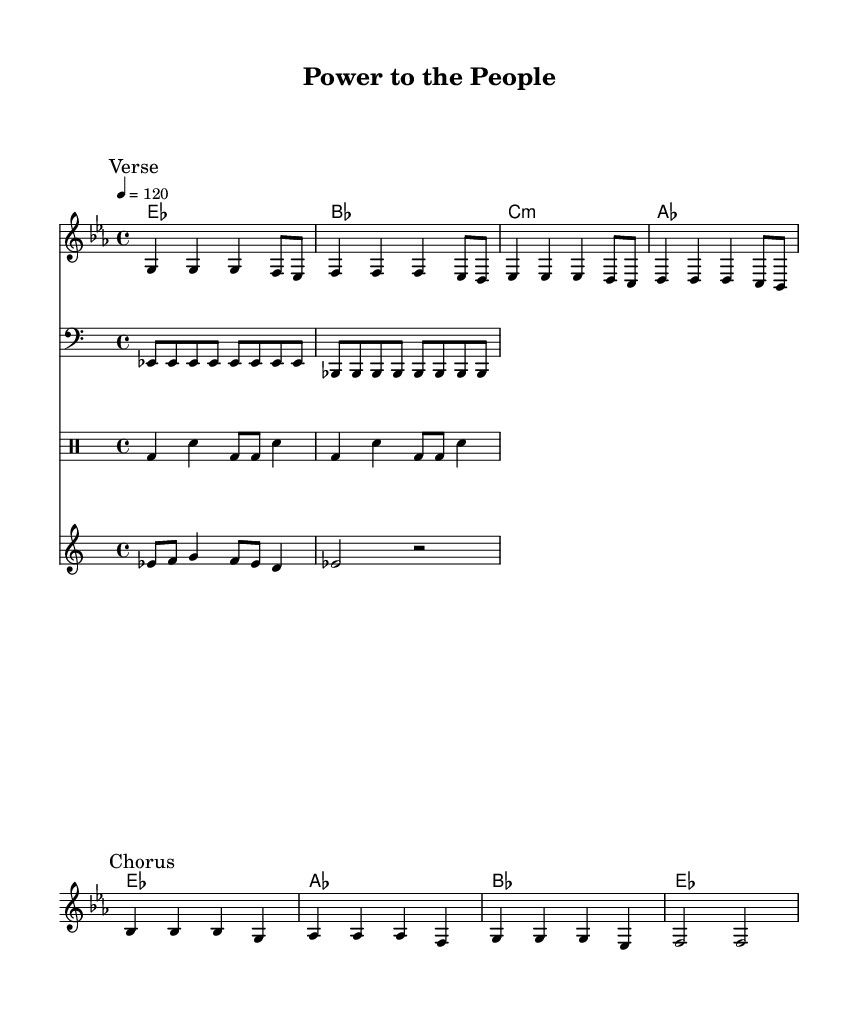What is the key signature of this music? The key signature is E flat major, which has three flats: B flat, E flat, and A flat. This is visible at the beginning of the staff where the flats are indicated.
Answer: E flat major What is the time signature of this music? The time signature is 4/4, which means there are four beats in each measure. This is indicated at the beginning of the music with the time signature notation.
Answer: 4/4 What is the tempo marking for this piece? The tempo marking is quarter note equals 120, which indicates a moderately fast pace for the music. This is noted above the staff.
Answer: 120 How many measures are in the verse section? The verse section contains four measures, as each measure is separated by vertical lines, and the verse is marked at the beginning of this section.
Answer: Four What is the final note of the chorus? The final note of the chorus is F, which is shown at the end of the chorus section in the melody line.
Answer: F What theme do the lyrics of the chorus convey? The lyrics of the chorus convey unity and empowerment, emphasizing collective strength and togetherness. This is inferred through the words that directly mention "power to the people" and "united we stand."
Answer: Unity and empowerment Which instrument plays the bass line? The bass line is played on a bass instrument, indicated by the clef used, which is the bass clef in the staff for the bass part.
Answer: Bass 